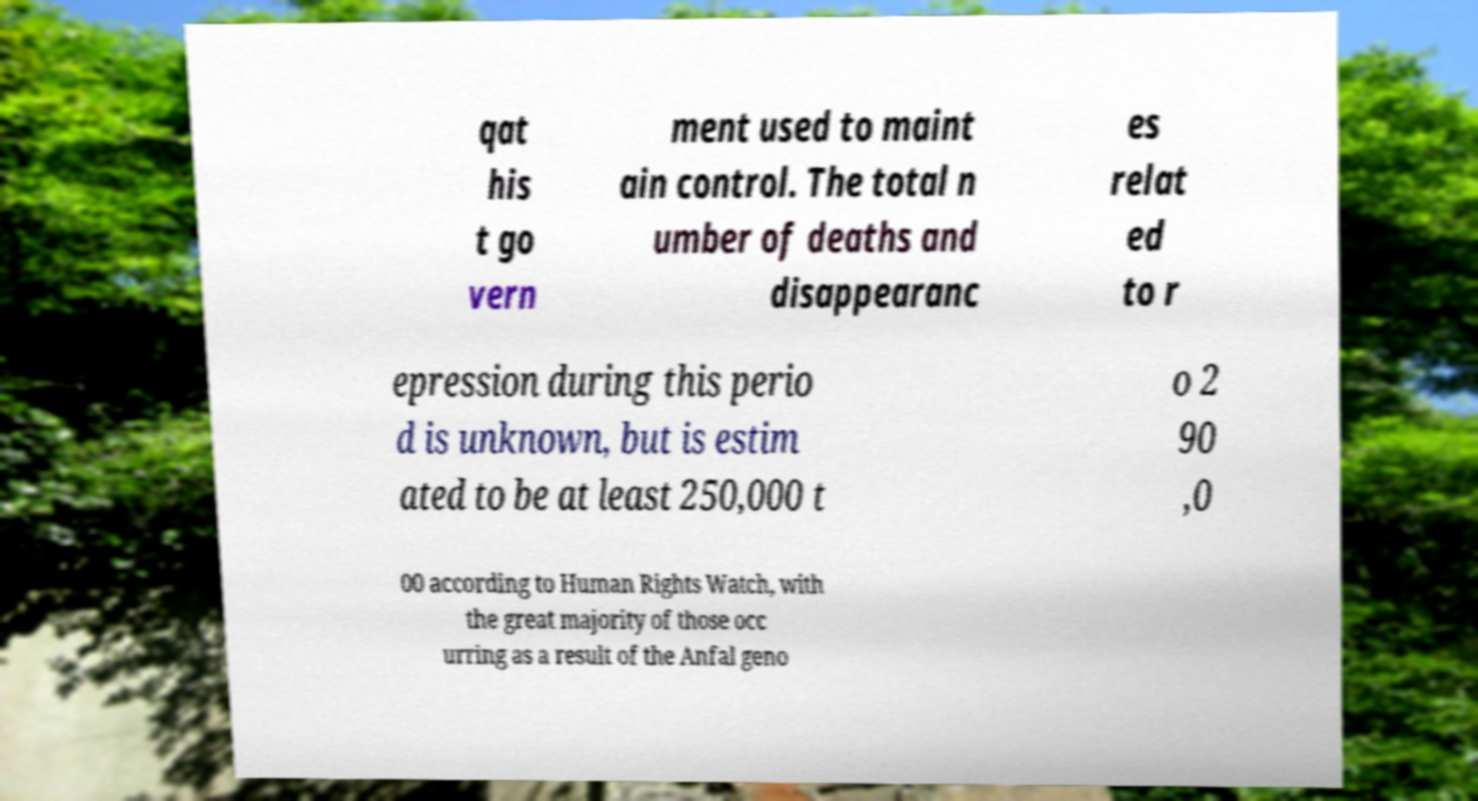There's text embedded in this image that I need extracted. Can you transcribe it verbatim? qat his t go vern ment used to maint ain control. The total n umber of deaths and disappearanc es relat ed to r epression during this perio d is unknown, but is estim ated to be at least 250,000 t o 2 90 ,0 00 according to Human Rights Watch, with the great majority of those occ urring as a result of the Anfal geno 